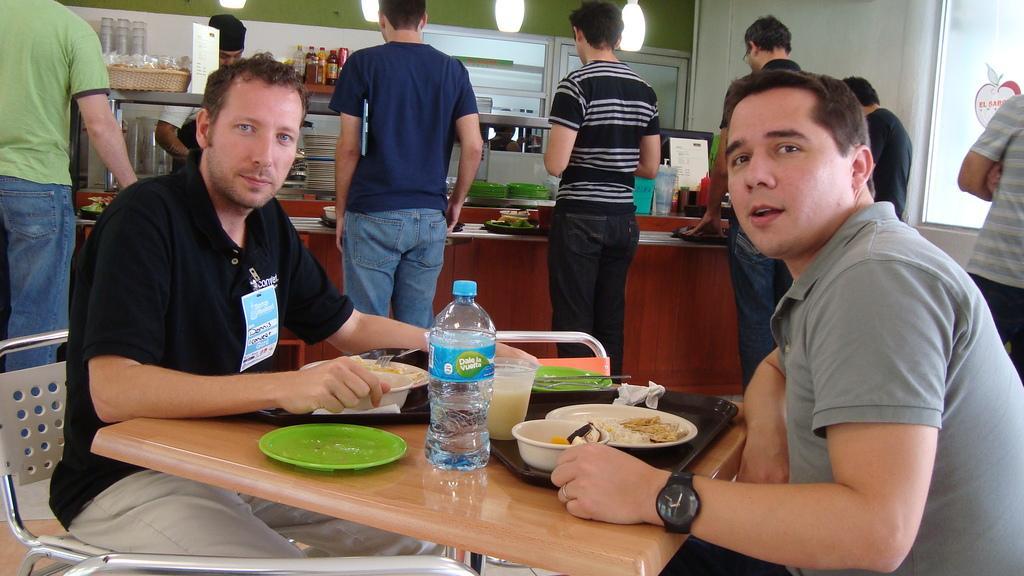Can you describe this image briefly? In the image there are two men and there is a table in between them. On the table there are some food items, behind the men few people are standing in front of the table. There are some plates kept on the table and behind the plates there are glasses, sauces and it looks like a person is doing some work. On the right side there is a billing counter and beside the billing counter there is a wall and and a window. 